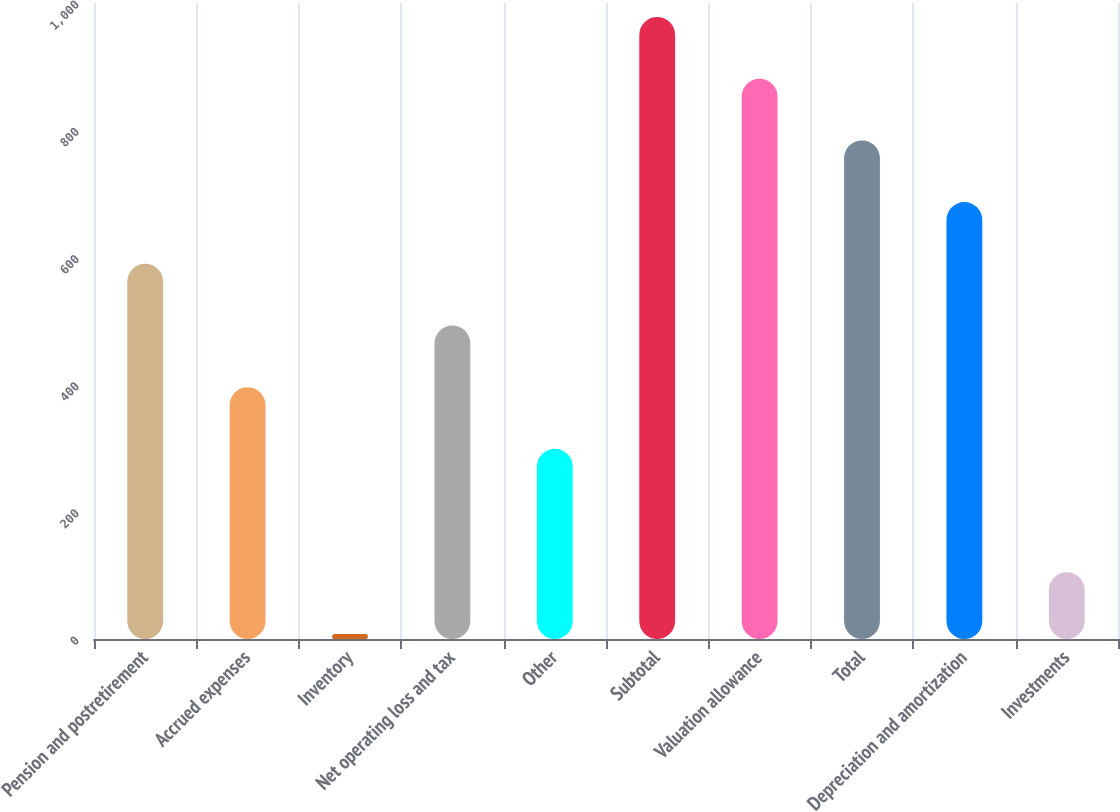Convert chart. <chart><loc_0><loc_0><loc_500><loc_500><bar_chart><fcel>Pension and postretirement<fcel>Accrued expenses<fcel>Inventory<fcel>Net operating loss and tax<fcel>Other<fcel>Subtotal<fcel>Valuation allowance<fcel>Total<fcel>Depreciation and amortization<fcel>Investments<nl><fcel>590<fcel>396<fcel>8<fcel>493<fcel>299<fcel>978<fcel>881<fcel>784<fcel>687<fcel>105<nl></chart> 